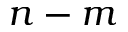Convert formula to latex. <formula><loc_0><loc_0><loc_500><loc_500>n - m</formula> 